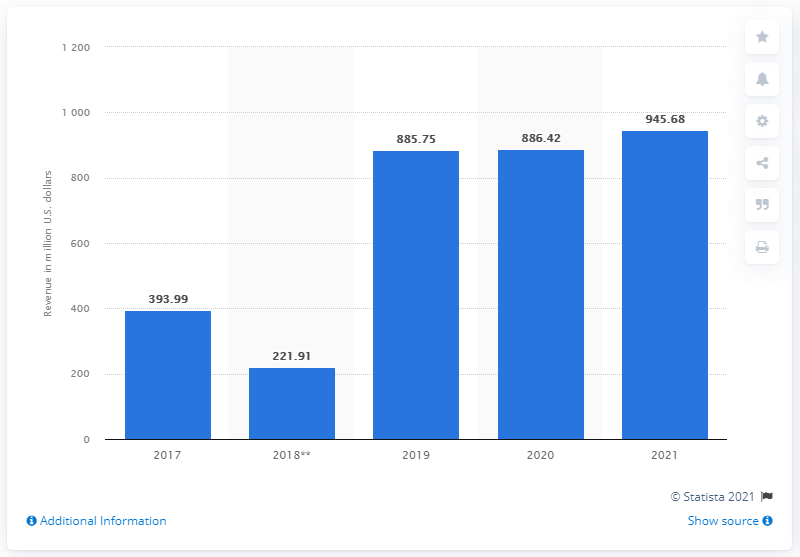Outline some significant characteristics in this image. In 2021, VF Corporation's work wear revenues were $945.68 million. 